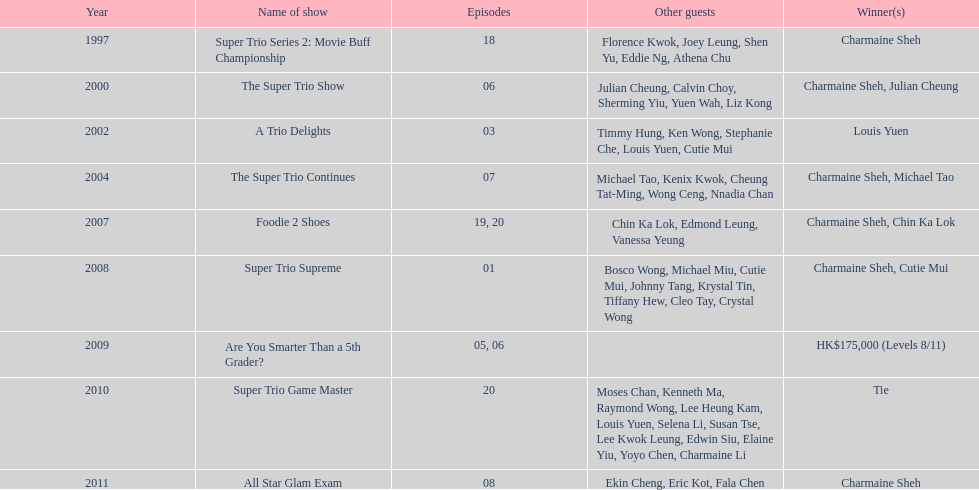How long has it been since chermaine sheh first appeared on a variety show? 17 years. 